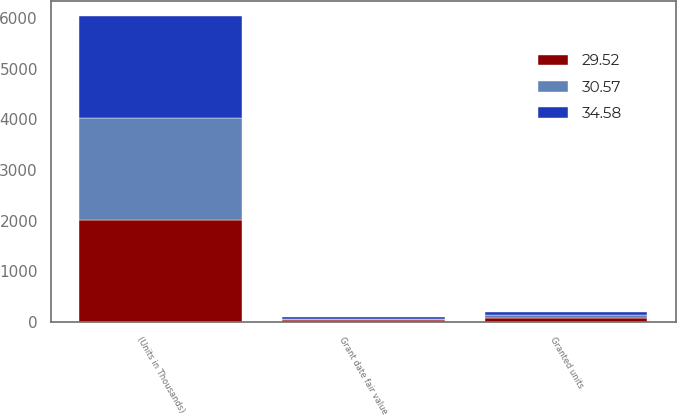Convert chart. <chart><loc_0><loc_0><loc_500><loc_500><stacked_bar_chart><ecel><fcel>(Units in Thousands)<fcel>Granted units<fcel>Grant date fair value<nl><fcel>34.58<fcel>2015<fcel>60<fcel>34.58<nl><fcel>30.57<fcel>2014<fcel>62<fcel>30.57<nl><fcel>29.52<fcel>2013<fcel>69<fcel>29.52<nl></chart> 